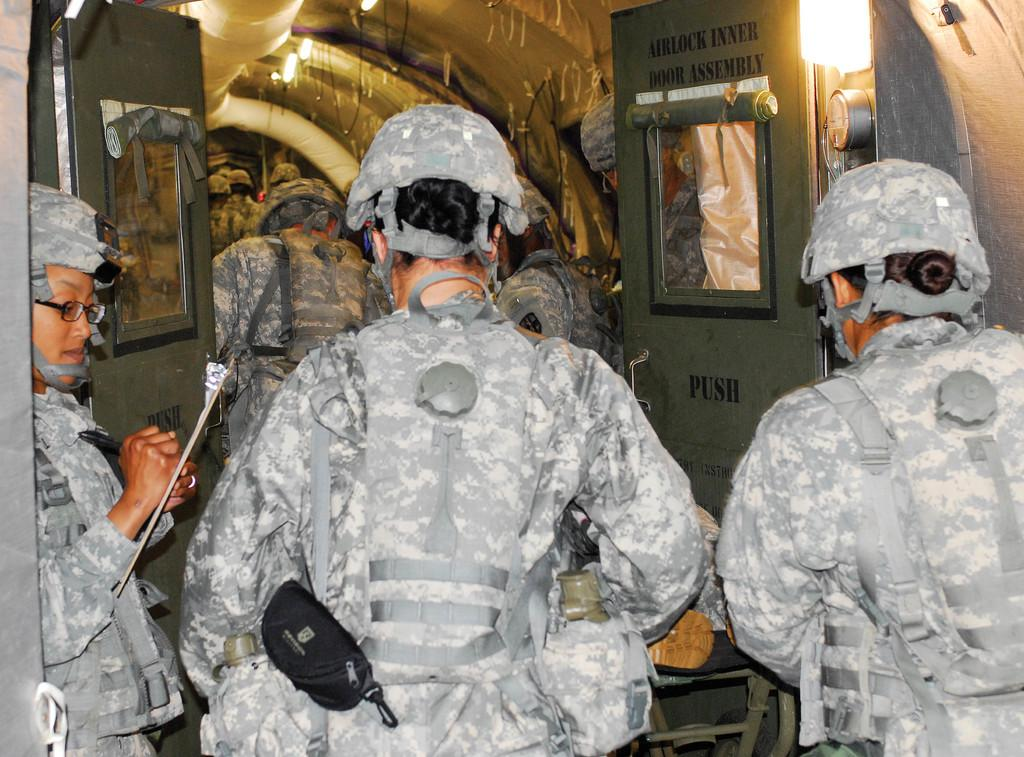How many people are in the image? There are many persons in the image. What type of clothing are the persons wearing? The persons are wearing camouflage dress. What type of headgear are the persons wearing? The persons are wearing helmets. What are the persons doing in the image? The persons are walking into a vehicle. What type of disease is being caused by the dust in the image? There is no dust present in the image, and therefore no disease can be caused by it. 